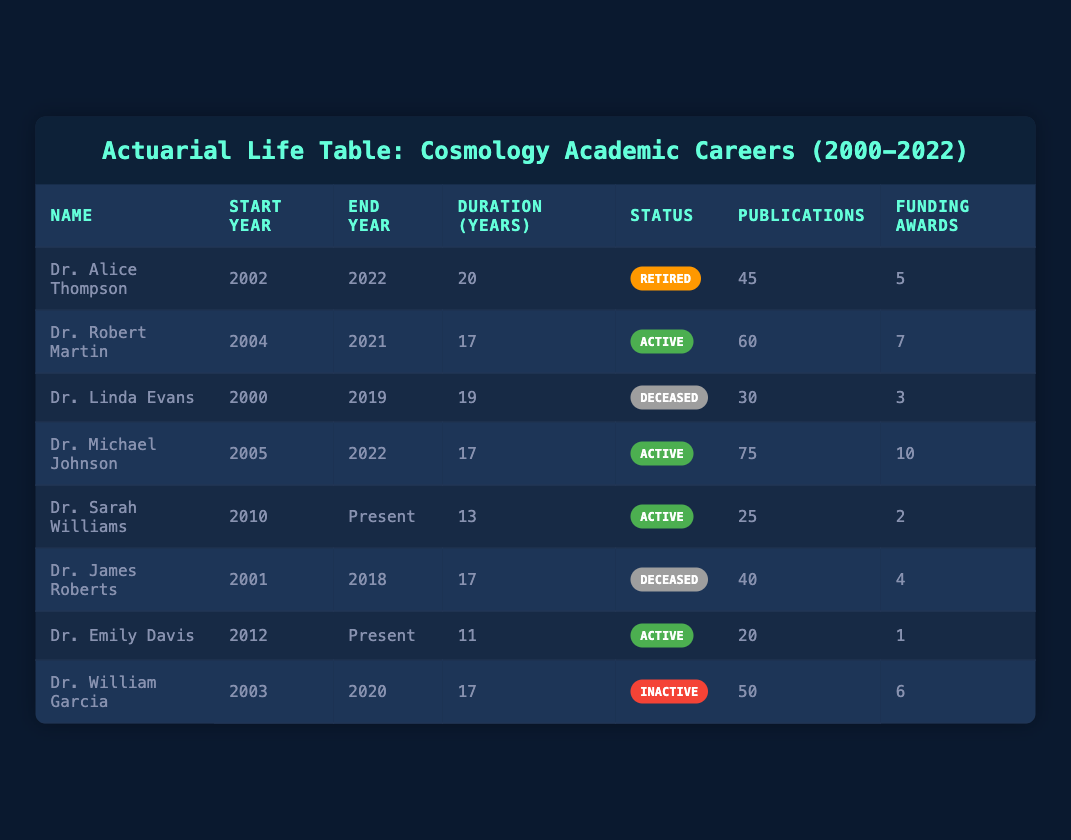What is the duration of Dr. Robert Martin's career? The table shows that Dr. Robert Martin's career lasted from 2004 to 2021, which is a duration of 17 years.
Answer: 17 years How many total publications have been made by all active researchers? The active researchers are Dr. Robert Martin, Dr. Michael Johnson, Dr. Sarah Williams, and Dr. Emily Davis. Their publications are 60, 75, 25, and 20, respectively. Adding these gives: 60 + 75 + 25 + 20 = 180 publications.
Answer: 180 publications Is it true that Dr. Linda Evans published more than 40 papers? According to the table, Dr. Linda Evans published 30 papers, which is less than 40.
Answer: No What is the average duration of the careers of deceased researchers in the table? The deceased researchers are Dr. Linda Evans and Dr. James Roberts, with durations of 19 and 17 years, respectively. To find the average, sum the durations: 19 + 17 = 36. Then divide by 2 (the number of researchers): 36 / 2 = 18 years.
Answer: 18 years Who has the highest number of funding awards among active researchers? Among the active researchers: Dr. Robert Martin has 7 awards, Dr. Michael Johnson has 10, Dr. Sarah Williams has 2, and Dr. Emily Davis has 1. The highest number is 10, belonging to Dr. Michael Johnson.
Answer: Dr. Michael Johnson How many researchers have a status of "Inactive"? The table shows that only Dr. William Garcia has a status of "Inactive."
Answer: 1 researcher What percentage of researchers documented in the table are active? There are 8 researchers total, with 4 currently active. To find the percentage, divide the number of active researchers by the total and multiply by 100: (4 / 8) * 100 = 50%.
Answer: 50% What is the sum of funding awards for all researchers who have retired? The only retired researcher is Dr. Alice Thompson with 5 funding awards. As there are no other retired researchers, the sum is simply 5.
Answer: 5 awards 